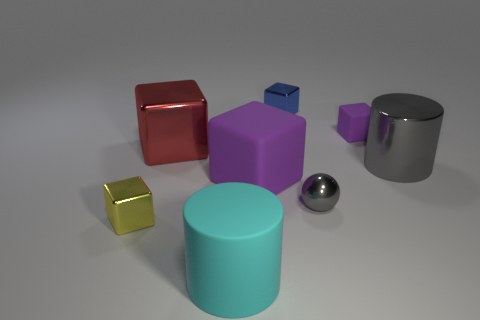What number of tiny cyan blocks have the same material as the big red thing?
Give a very brief answer. 0. There is a red object on the right side of the tiny yellow metal thing; is it the same shape as the blue object?
Provide a short and direct response. Yes. There is a big object in front of the large purple thing; what is its shape?
Offer a very short reply. Cylinder. The other thing that is the same color as the tiny rubber thing is what size?
Your answer should be very brief. Large. What material is the yellow block?
Provide a succinct answer. Metal. What is the color of the matte cube that is the same size as the cyan cylinder?
Provide a short and direct response. Purple. What is the shape of the large object that is the same color as the shiny sphere?
Give a very brief answer. Cylinder. Is the blue shiny object the same shape as the yellow shiny thing?
Provide a succinct answer. Yes. What material is the block that is both on the left side of the tiny purple matte thing and behind the big red metallic cube?
Your response must be concise. Metal. What size is the red cube?
Your answer should be compact. Large. 